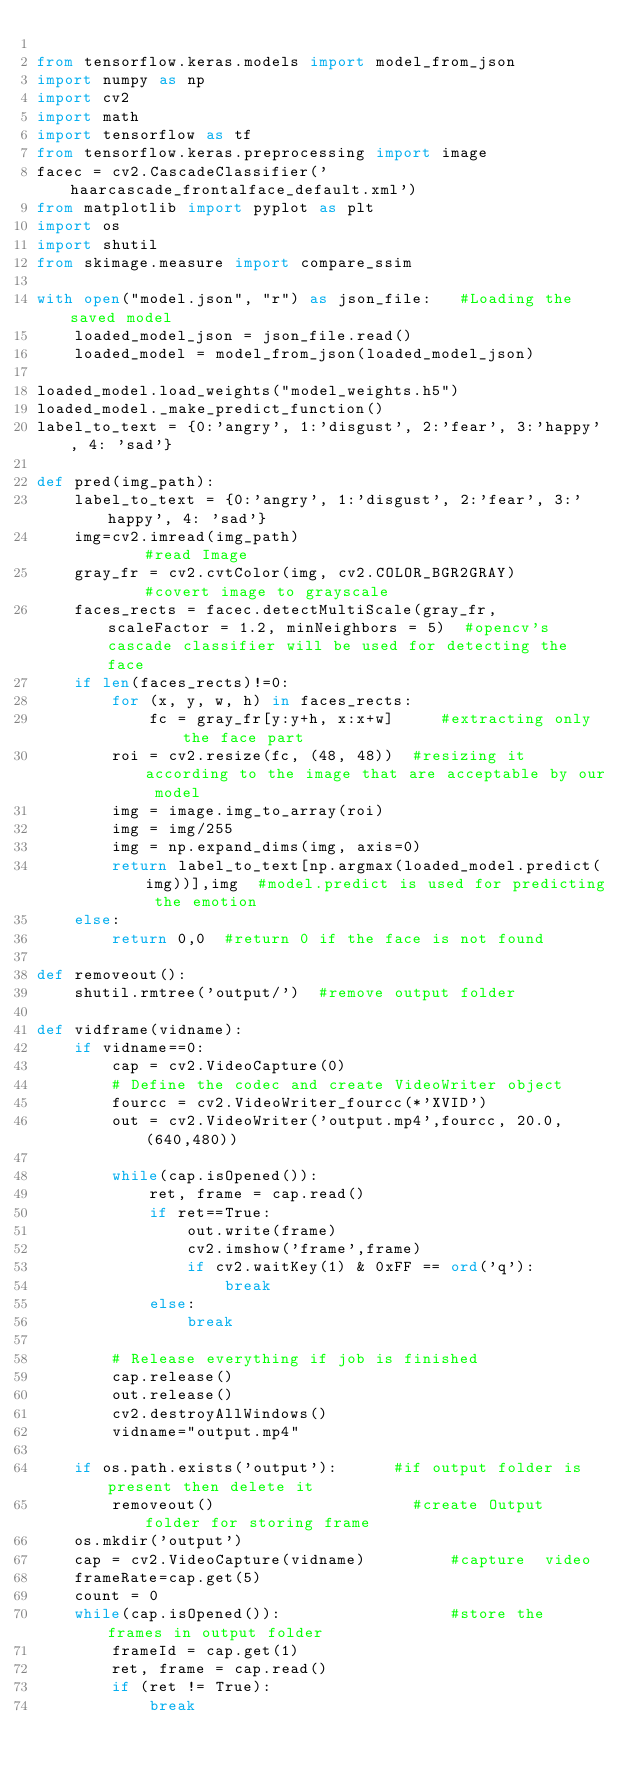<code> <loc_0><loc_0><loc_500><loc_500><_Python_>
from tensorflow.keras.models import model_from_json
import numpy as np
import cv2
import math
import tensorflow as tf
from tensorflow.keras.preprocessing import image
facec = cv2.CascadeClassifier('haarcascade_frontalface_default.xml')
from matplotlib import pyplot as plt
import os
import shutil
from skimage.measure import compare_ssim

with open("model.json", "r") as json_file:   #Loading the saved model
    loaded_model_json = json_file.read()
    loaded_model = model_from_json(loaded_model_json)

loaded_model.load_weights("model_weights.h5")
loaded_model._make_predict_function()
label_to_text = {0:'angry', 1:'disgust', 2:'fear', 3:'happy', 4: 'sad'}

def pred(img_path):  
    label_to_text = {0:'angry', 1:'disgust', 2:'fear', 3:'happy', 4: 'sad'}  
    img=cv2.imread(img_path)									#read Image
    gray_fr = cv2.cvtColor(img, cv2.COLOR_BGR2GRAY)				#covert image to grayscale
    faces_rects = facec.detectMultiScale(gray_fr, scaleFactor = 1.2, minNeighbors = 5)  #opencv's cascade classifier will be used for detecting the face
    if len(faces_rects)!=0:
        for (x, y, w, h) in faces_rects:
            fc = gray_fr[y:y+h, x:x+w]     #extracting only the face part
        roi = cv2.resize(fc, (48, 48))	#resizing it according to the image that are acceptable by our model
        img = image.img_to_array(roi)
        img = img/255
        img = np.expand_dims(img, axis=0)
        return label_to_text[np.argmax(loaded_model.predict(img))],img  #model.predict is used for predicting the emotion
    else:
        return 0,0  #return 0 if the face is not found

def removeout():
    shutil.rmtree('output/')  #remove output folder

def vidframe(vidname):
	if vidname==0:
		cap = cv2.VideoCapture(0)
		# Define the codec and create VideoWriter object
		fourcc = cv2.VideoWriter_fourcc(*'XVID')
		out = cv2.VideoWriter('output.mp4',fourcc, 20.0, (640,480))

		while(cap.isOpened()):
		    ret, frame = cap.read()
		    if ret==True:
		        out.write(frame)
		        cv2.imshow('frame',frame)
		        if cv2.waitKey(1) & 0xFF == ord('q'):
		            break
		    else:
		        break

		# Release everything if job is finished
		cap.release()
		out.release()
		cv2.destroyAllWindows()
		vidname="output.mp4"

	if os.path.exists('output'):      #if output folder is present then delete it
		removeout()						#create Output folder for storing frame
	os.mkdir('output')
	cap = cv2.VideoCapture(vidname)			#capture  video
	frameRate=cap.get(5)					
	count = 0
	while(cap.isOpened()):					#store the frames in output folder
		frameId = cap.get(1)
		ret, frame = cap.read()
		if (ret != True):
			break</code> 